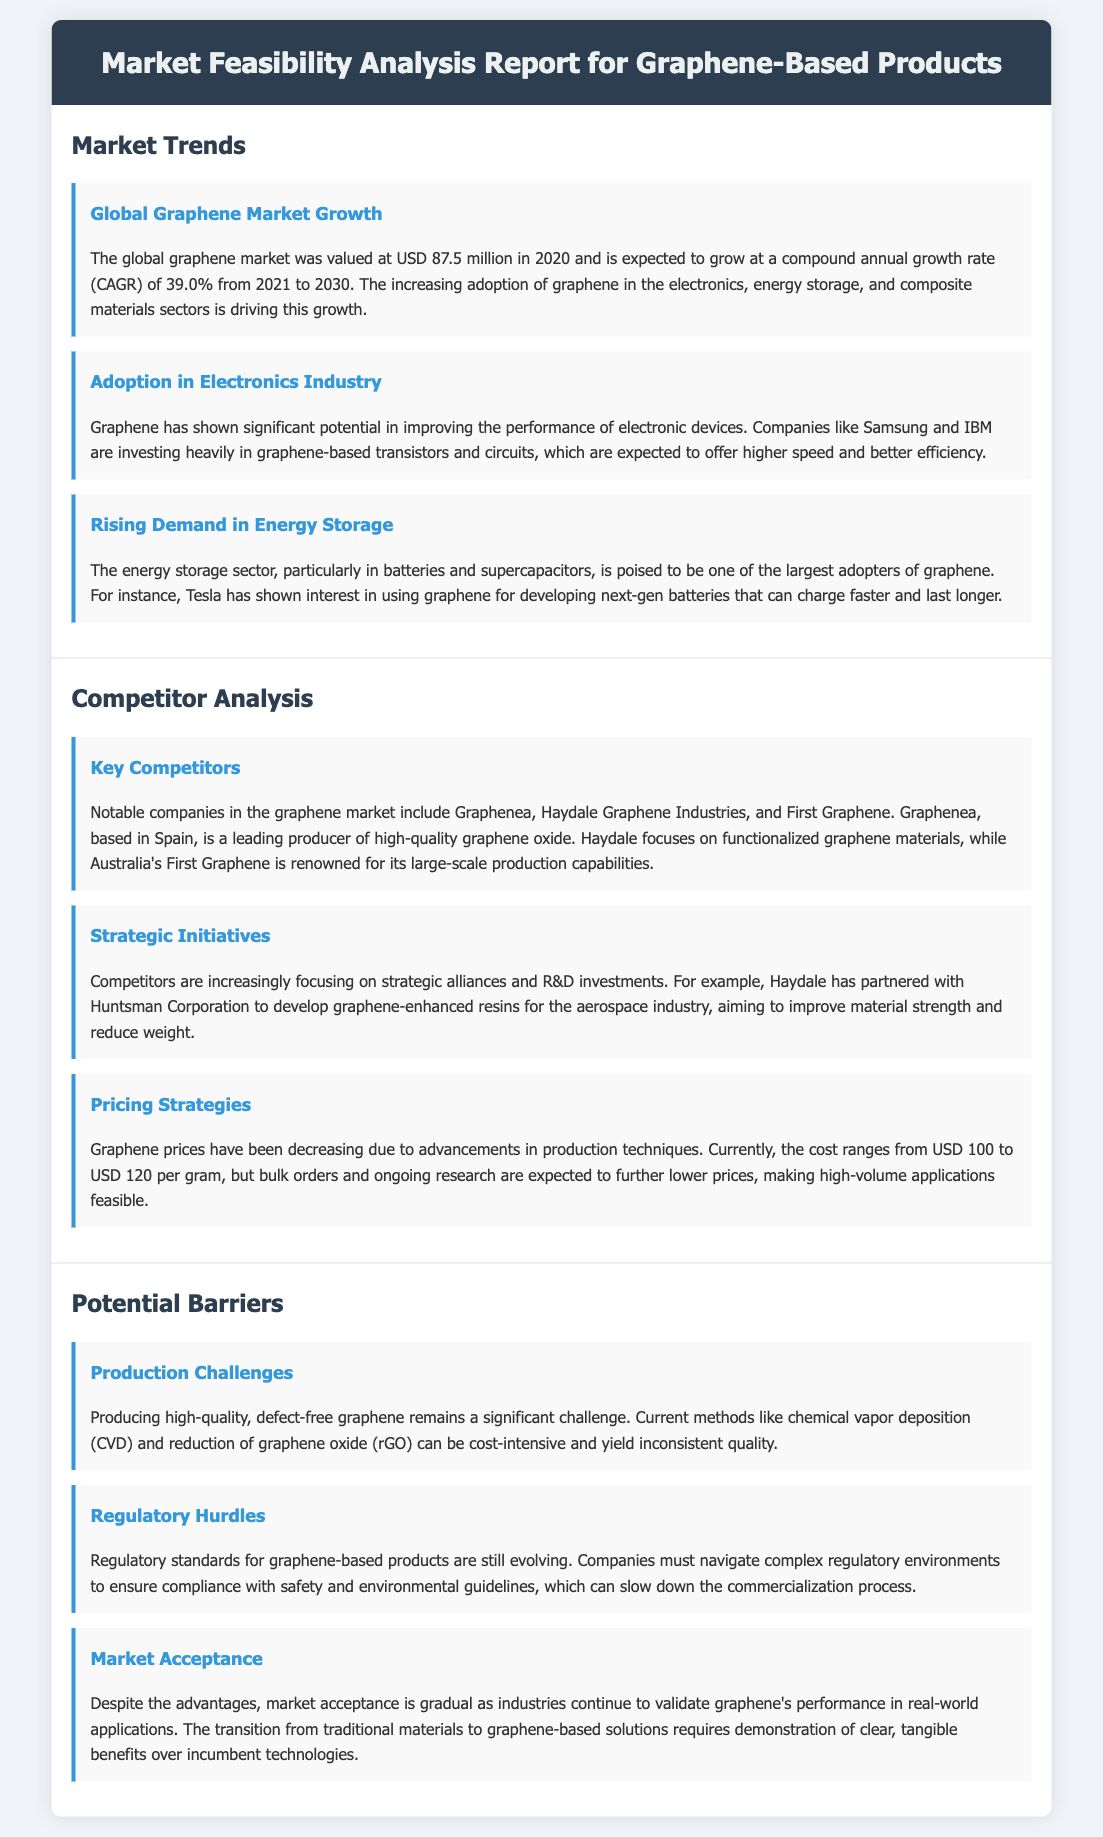What was the global graphene market value in 2020? The document states that the global graphene market was valued at USD 87.5 million in 2020.
Answer: USD 87.5 million What is the expected CAGR for the graphene market from 2021 to 2030? The document indicates that the graphene market is expected to grow at a CAGR of 39.0% from 2021 to 2030.
Answer: 39.0% Which companies are mentioned as key competitors in the graphene market? The document lists Graphenea, Haydale Graphene Industries, and First Graphene as notable companies in the market.
Answer: Graphenea, Haydale Graphene Industries, and First Graphene What significant challenge is associated with producing graphene? The document highlights that producing high-quality, defect-free graphene remains a significant challenge.
Answer: High-quality, defect-free graphene Which company is involved with graphene-enhanced resins for the aerospace industry? The document states that Haydale has partnered with Huntsman Corporation to develop graphene-enhanced resins.
Answer: Haydale What is the current price range for graphene per gram? The document notes that the cost of graphene currently ranges from USD 100 to USD 120 per gram.
Answer: USD 100 to USD 120 What type of industry is increasing its adoption of graphene according to the report? The document mentions that the electronics industry is significantly adopting graphene.
Answer: Electronics industry What is a barrier to the acceptance of graphene-based products in the market? The document states that market acceptance is gradual as industries continue to validate graphene's performance.
Answer: Market acceptance What production method for graphene is mentioned as cost-intensive? The document specifies that the chemical vapor deposition (CVD) method can be cost-intensive.
Answer: Chemical vapor deposition (CVD) Which sector is poised to be a large adopter of graphene for batteries? The document indicates that the energy storage sector is expected to adopt graphene widely.
Answer: Energy storage sector 